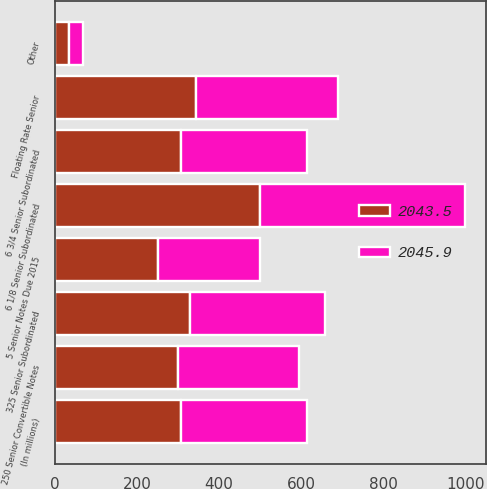Convert chart. <chart><loc_0><loc_0><loc_500><loc_500><stacked_bar_chart><ecel><fcel>(In millions)<fcel>250 Senior Convertible Notes<fcel>Floating Rate Senior<fcel>325 Senior Subordinated<fcel>5 Senior Notes Due 2015<fcel>6 3/4 Senior Subordinated<fcel>6 1/8 Senior Subordinated<fcel>Other<nl><fcel>2045.9<fcel>306.8<fcel>295.4<fcel>344.4<fcel>329.3<fcel>250<fcel>306.3<fcel>500<fcel>32.9<nl><fcel>2043.5<fcel>306.8<fcel>300<fcel>344.4<fcel>329.3<fcel>250<fcel>307.3<fcel>500<fcel>33.9<nl></chart> 